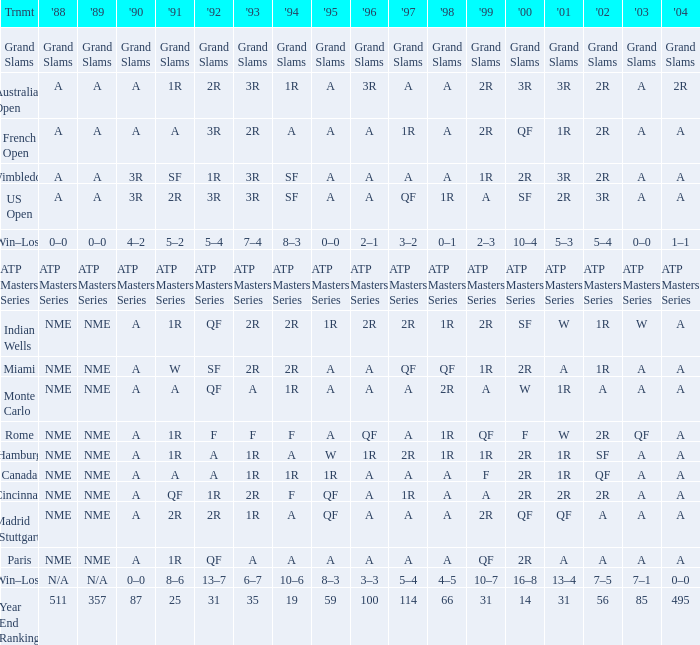What shows for 1992 when 1988 is A, at the Australian Open? 2R. 